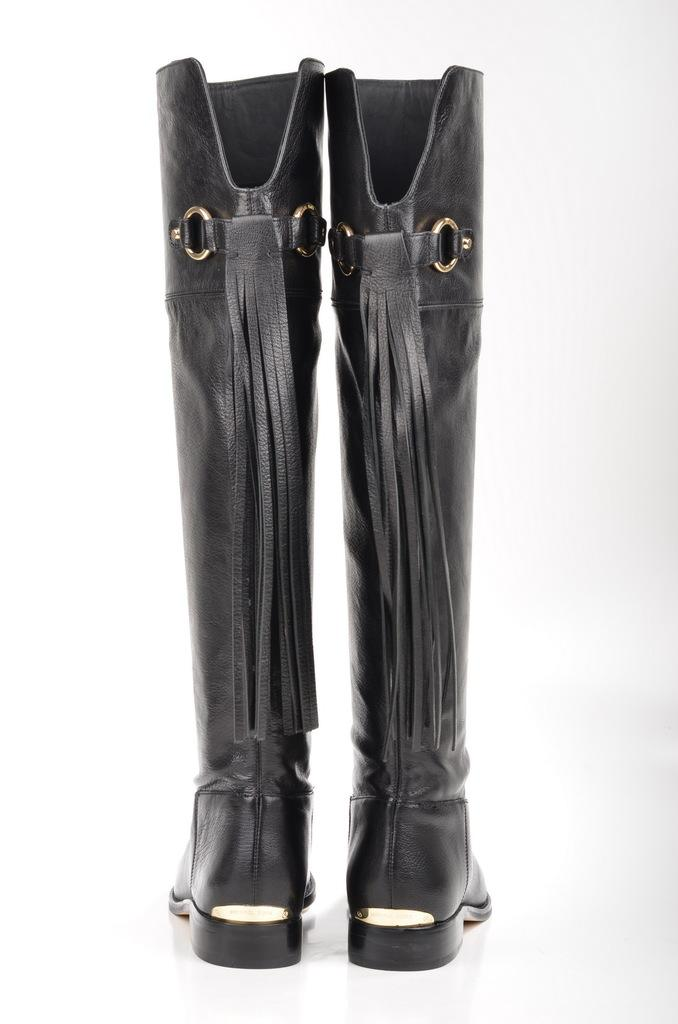What type of footwear is present in the image? There are boots in the image. What color are the boots? The boots are black in color. How many cats are sitting on the tramp in the image? There are no cats or tramp present in the image; it only features black boots. What type of polish is applied to the boots in the image? There is no information about any polish applied to the boots in the image. 